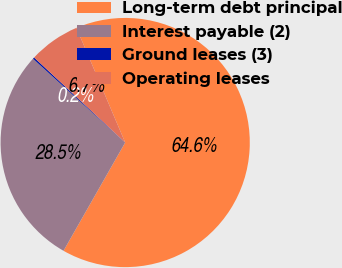<chart> <loc_0><loc_0><loc_500><loc_500><pie_chart><fcel>Long-term debt principal<fcel>Interest payable (2)<fcel>Ground leases (3)<fcel>Operating leases<nl><fcel>64.63%<fcel>28.5%<fcel>0.21%<fcel>6.65%<nl></chart> 